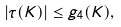Convert formula to latex. <formula><loc_0><loc_0><loc_500><loc_500>| \tau ( K ) | \leq g _ { 4 } ( K ) ,</formula> 